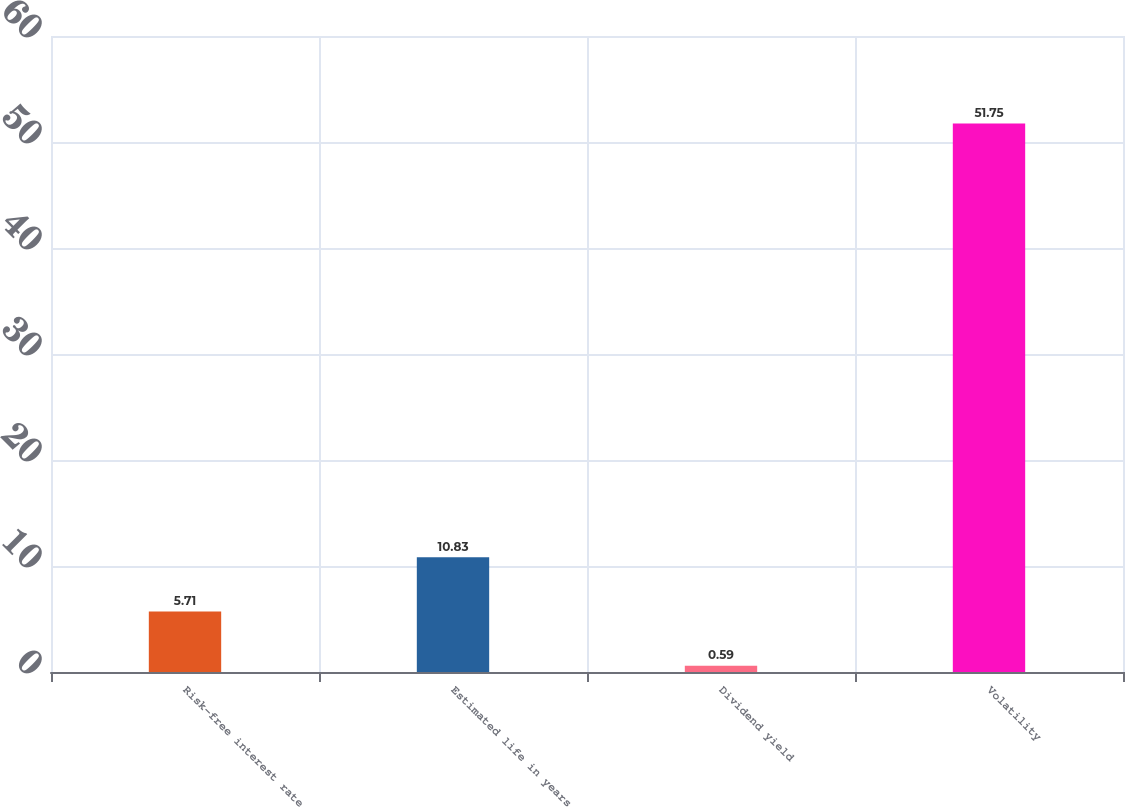<chart> <loc_0><loc_0><loc_500><loc_500><bar_chart><fcel>Risk-free interest rate<fcel>Estimated life in years<fcel>Dividend yield<fcel>Volatility<nl><fcel>5.71<fcel>10.83<fcel>0.59<fcel>51.75<nl></chart> 